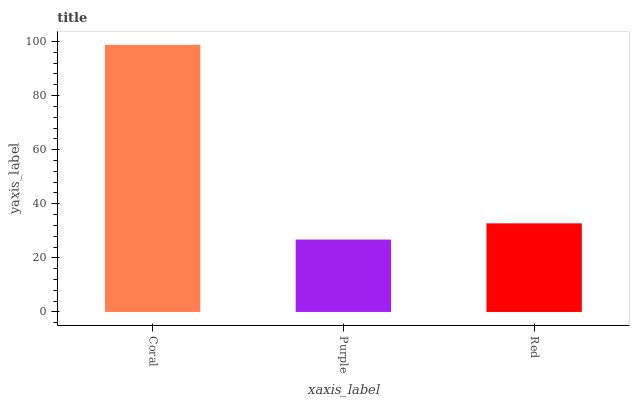Is Purple the minimum?
Answer yes or no. Yes. Is Coral the maximum?
Answer yes or no. Yes. Is Red the minimum?
Answer yes or no. No. Is Red the maximum?
Answer yes or no. No. Is Red greater than Purple?
Answer yes or no. Yes. Is Purple less than Red?
Answer yes or no. Yes. Is Purple greater than Red?
Answer yes or no. No. Is Red less than Purple?
Answer yes or no. No. Is Red the high median?
Answer yes or no. Yes. Is Red the low median?
Answer yes or no. Yes. Is Purple the high median?
Answer yes or no. No. Is Purple the low median?
Answer yes or no. No. 